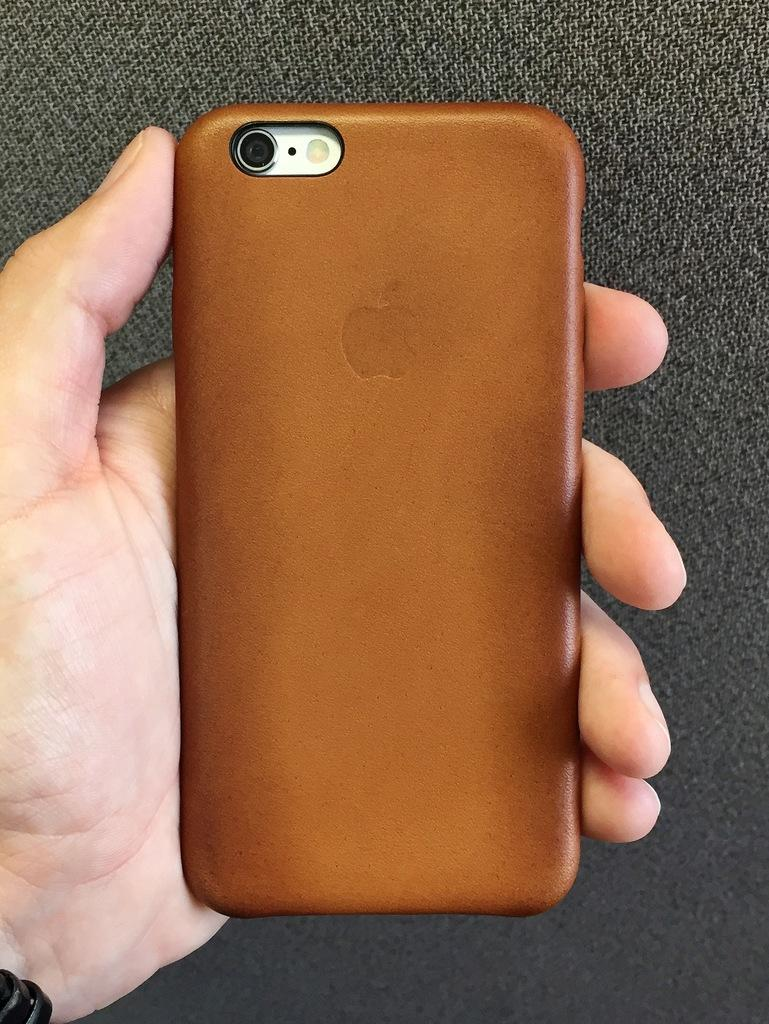What can be seen in the image? There is a hand in the image. What is the hand holding? The hand is holding a phone. How many books are being carried by the carriage in the image? There is no carriage or books present in the image; it only features a hand holding a phone. 